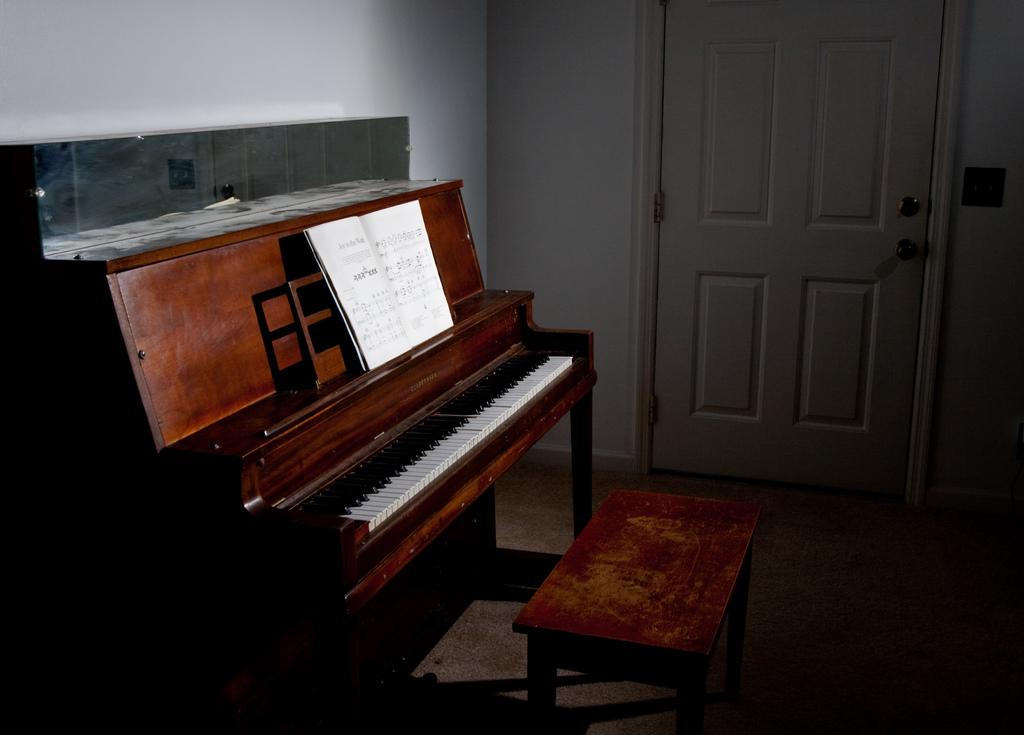What type of space is depicted in the image? There is a room in the image. What musical instrument can be seen in the room? There is a piano in the room. What is placed on the piano? There is a musical note book on the piano. What piece of furniture is present in the room? There is a table in the room. What can be seen in the background of the image? There is a wall and a door in the background of the image. How many horses are visible in the room in the image? There are no horses present in the image; it features a room with a piano, musical note book, table, wall, and door. What type of lamp is placed on the piano? There is no lamp present on the piano in the image. 